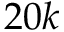<formula> <loc_0><loc_0><loc_500><loc_500>2 0 k</formula> 